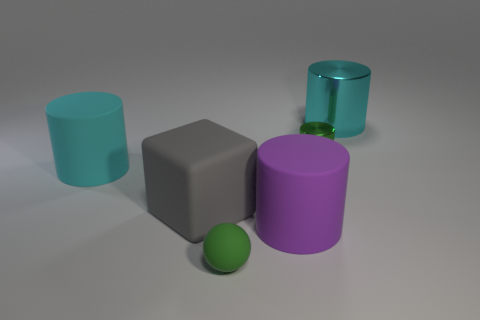Is the color of the small cylinder the same as the small ball?
Ensure brevity in your answer.  Yes. There is a tiny metal thing that is the same color as the sphere; what is its shape?
Keep it short and to the point. Cylinder. Does the big metallic thing have the same color as the matte cylinder that is on the left side of the purple thing?
Give a very brief answer. Yes. What size is the rubber sphere that is the same color as the small metallic cylinder?
Your response must be concise. Small. There is another metallic object that is the same shape as the small green metal object; what size is it?
Your answer should be compact. Large. Do the gray object and the green metallic thing have the same shape?
Keep it short and to the point. No. What size is the cyan cylinder that is to the left of the tiny green matte thing that is in front of the large metal cylinder?
Ensure brevity in your answer.  Large. There is another tiny thing that is the same shape as the cyan shiny object; what color is it?
Your response must be concise. Green. How many small shiny objects have the same color as the tiny matte object?
Provide a short and direct response. 1. The gray rubber thing has what size?
Offer a terse response. Large. 